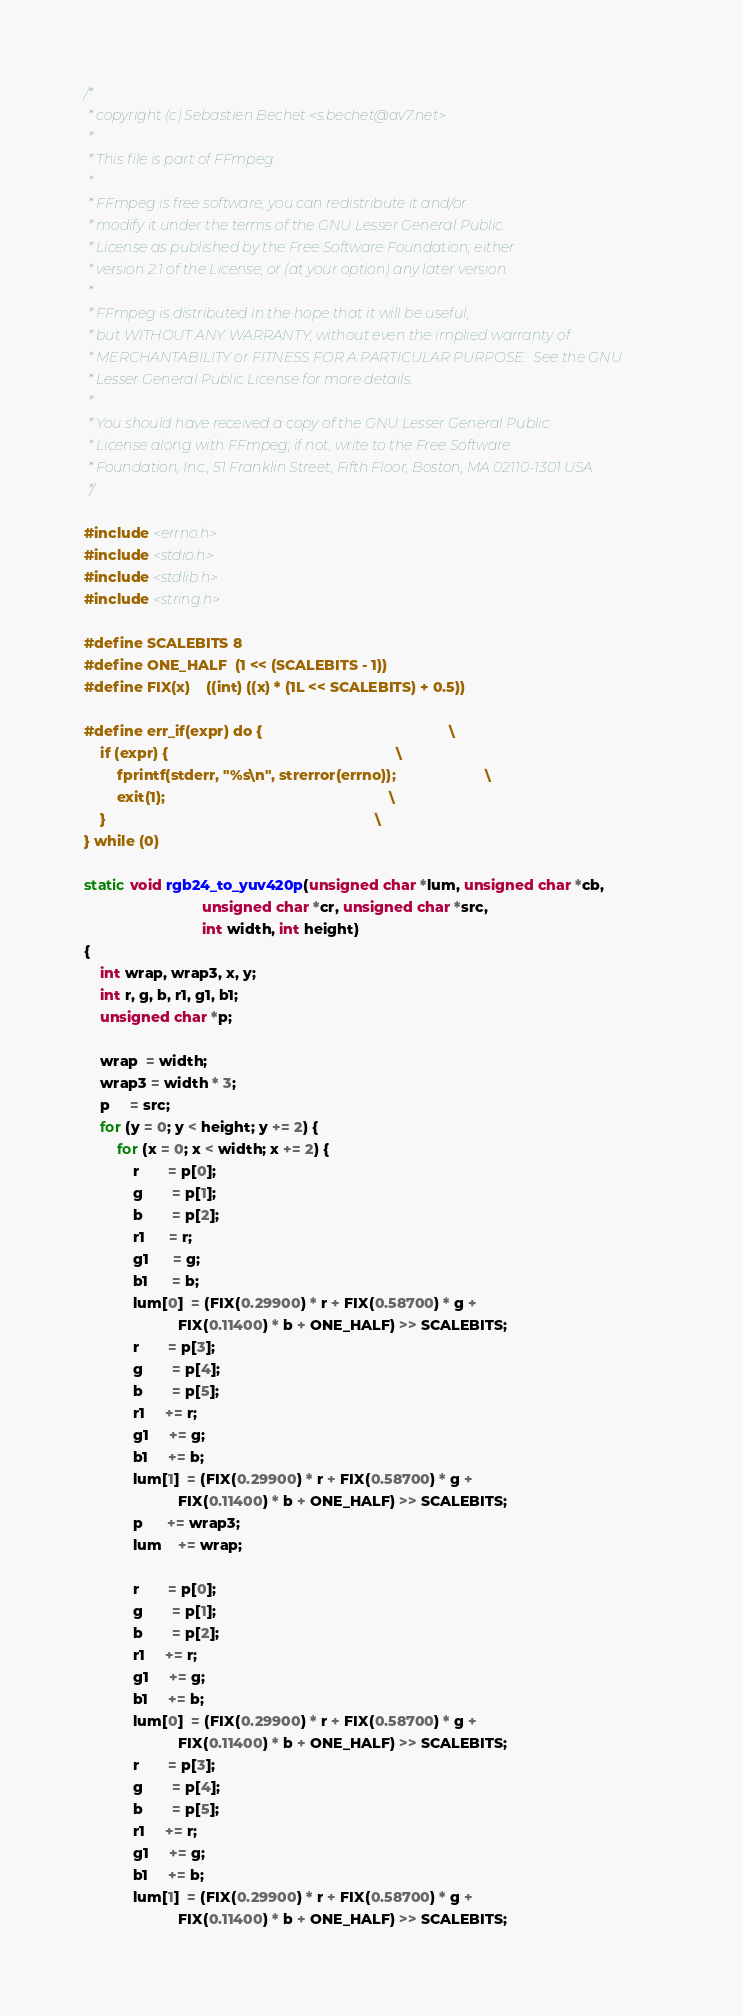<code> <loc_0><loc_0><loc_500><loc_500><_C_>/*
 * copyright (c) Sebastien Bechet <s.bechet@av7.net>
 *
 * This file is part of FFmpeg.
 *
 * FFmpeg is free software; you can redistribute it and/or
 * modify it under the terms of the GNU Lesser General Public
 * License as published by the Free Software Foundation; either
 * version 2.1 of the License, or (at your option) any later version.
 *
 * FFmpeg is distributed in the hope that it will be useful,
 * but WITHOUT ANY WARRANTY; without even the implied warranty of
 * MERCHANTABILITY or FITNESS FOR A PARTICULAR PURPOSE.  See the GNU
 * Lesser General Public License for more details.
 *
 * You should have received a copy of the GNU Lesser General Public
 * License along with FFmpeg; if not, write to the Free Software
 * Foundation, Inc., 51 Franklin Street, Fifth Floor, Boston, MA 02110-1301 USA
 */

#include <errno.h>
#include <stdio.h>
#include <stdlib.h>
#include <string.h>

#define SCALEBITS 8
#define ONE_HALF  (1 << (SCALEBITS - 1))
#define FIX(x)    ((int) ((x) * (1L << SCALEBITS) + 0.5))

#define err_if(expr) do {                                              \
    if (expr) {                                                        \
        fprintf(stderr, "%s\n", strerror(errno));                      \
        exit(1);                                                       \
    }                                                                  \
} while (0)

static void rgb24_to_yuv420p(unsigned char *lum, unsigned char *cb,
                             unsigned char *cr, unsigned char *src,
                             int width, int height)
{
    int wrap, wrap3, x, y;
    int r, g, b, r1, g1, b1;
    unsigned char *p;

    wrap  = width;
    wrap3 = width * 3;
    p     = src;
    for (y = 0; y < height; y += 2) {
        for (x = 0; x < width; x += 2) {
            r       = p[0];
            g       = p[1];
            b       = p[2];
            r1      = r;
            g1      = g;
            b1      = b;
            lum[0]  = (FIX(0.29900) * r + FIX(0.58700) * g +
                       FIX(0.11400) * b + ONE_HALF) >> SCALEBITS;
            r       = p[3];
            g       = p[4];
            b       = p[5];
            r1     += r;
            g1     += g;
            b1     += b;
            lum[1]  = (FIX(0.29900) * r + FIX(0.58700) * g +
                       FIX(0.11400) * b + ONE_HALF) >> SCALEBITS;
            p      += wrap3;
            lum    += wrap;

            r       = p[0];
            g       = p[1];
            b       = p[2];
            r1     += r;
            g1     += g;
            b1     += b;
            lum[0]  = (FIX(0.29900) * r + FIX(0.58700) * g +
                       FIX(0.11400) * b + ONE_HALF) >> SCALEBITS;
            r       = p[3];
            g       = p[4];
            b       = p[5];
            r1     += r;
            g1     += g;
            b1     += b;
            lum[1]  = (FIX(0.29900) * r + FIX(0.58700) * g +
                       FIX(0.11400) * b + ONE_HALF) >> SCALEBITS;
</code> 